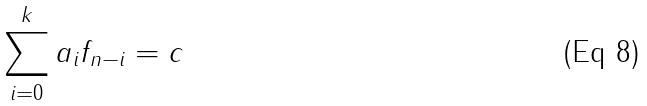<formula> <loc_0><loc_0><loc_500><loc_500>\sum _ { i = 0 } ^ { k } a _ { i } f _ { n - i } = c</formula> 